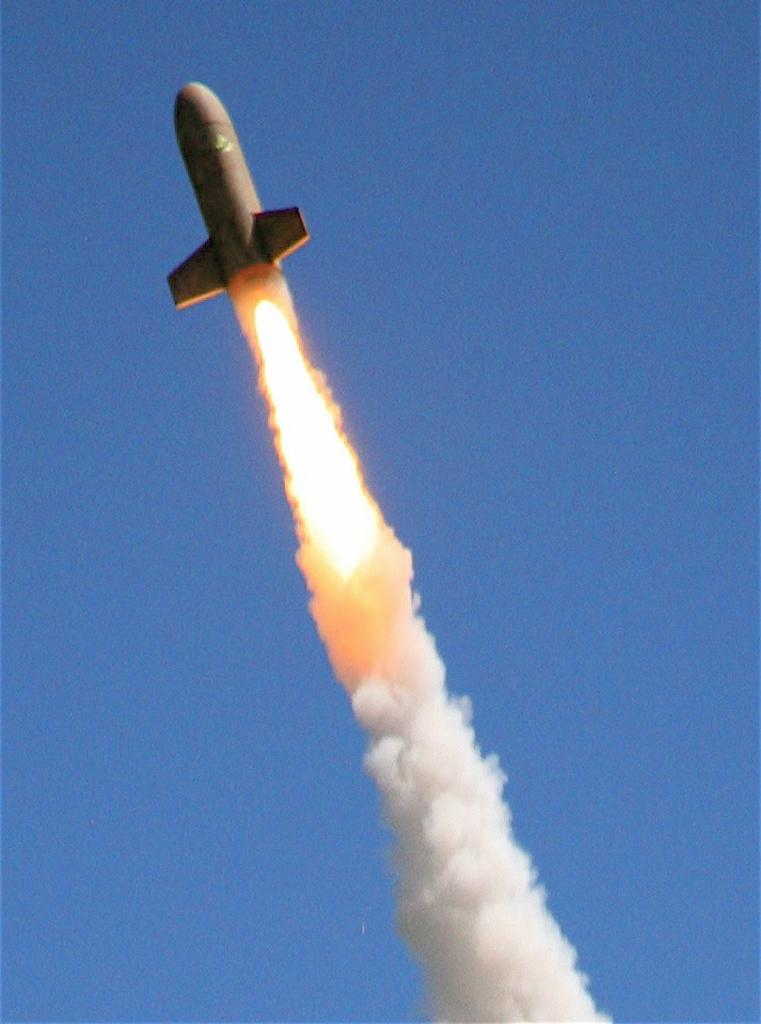What is the main subject of the image? There is a rocket in the image. What can be seen below the rocket? Fire and fumes are present below the rocket. What is visible in the background of the image? The sky is visible in the background of the image. What type of juice is being served in the rocket? There is no juice present in the image, as it features a rocket with fire and fumes below it. 